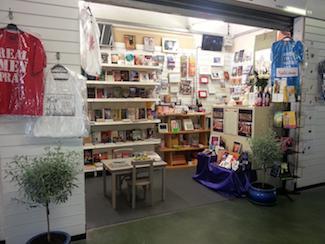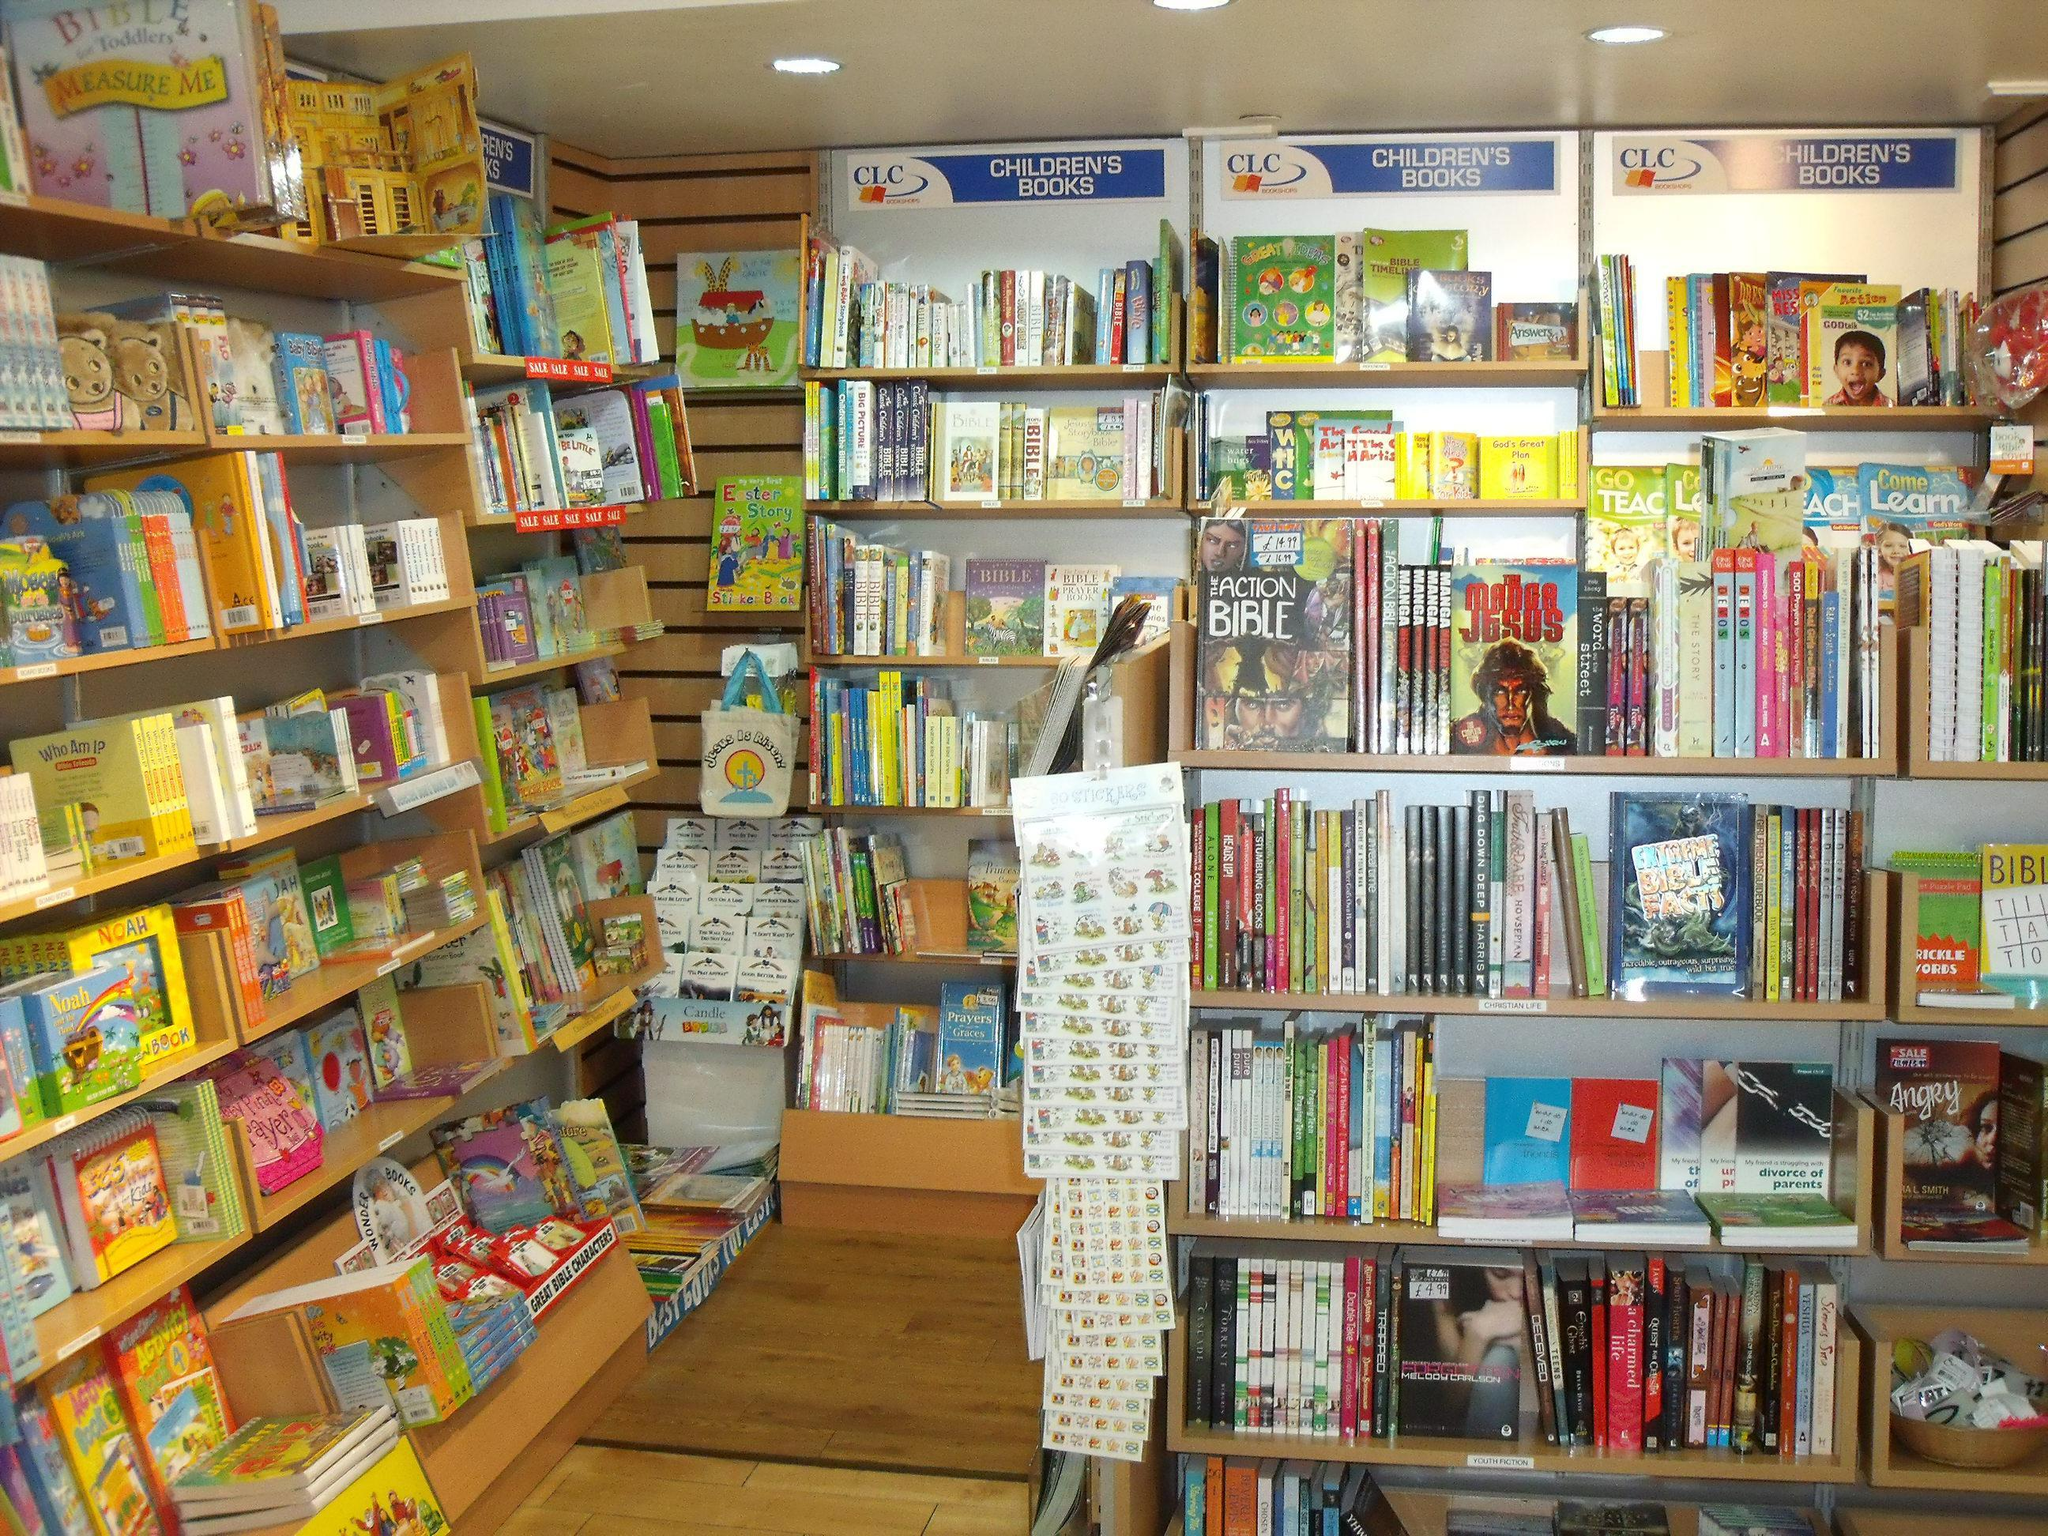The first image is the image on the left, the second image is the image on the right. Assess this claim about the two images: "The right image shows a bookstore with a blue exterior, a large display window only to the left of one door, and four rectangular panes of glass under its sign.". Correct or not? Answer yes or no. No. The first image is the image on the left, the second image is the image on the right. Examine the images to the left and right. Is the description "The bookstore name is in white with a blue background." accurate? Answer yes or no. No. 